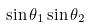Convert formula to latex. <formula><loc_0><loc_0><loc_500><loc_500>\sin \theta _ { 1 } \sin \theta _ { 2 }</formula> 